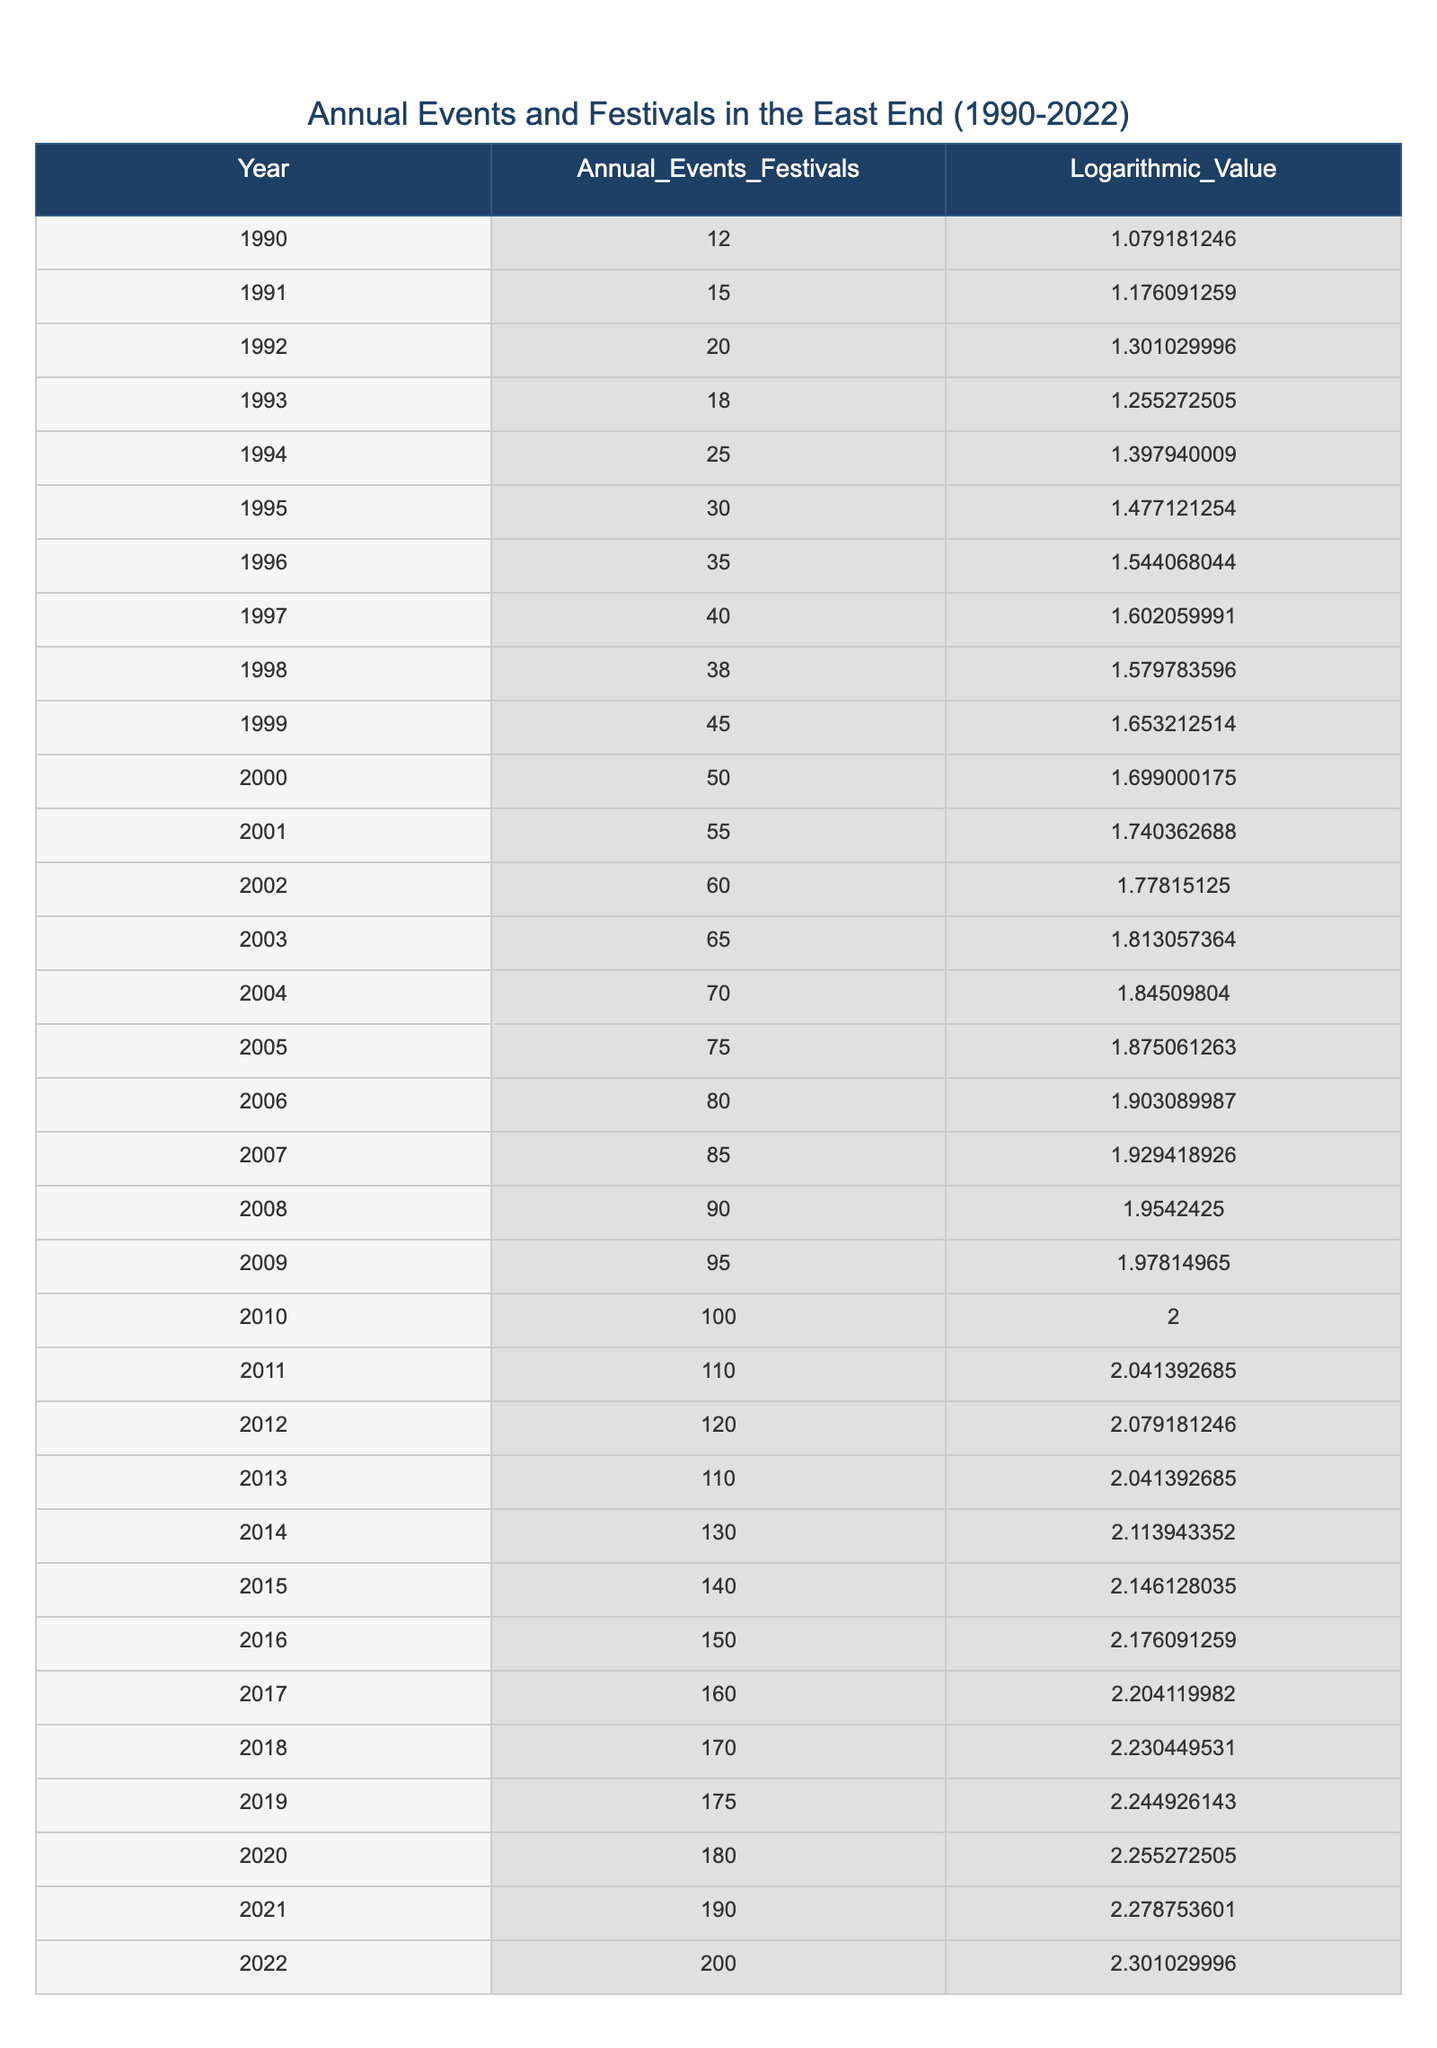What was the annual number of recorded events or festivals in 1995? The value in the row for the year 1995 under the "Annual_Events_Festivals" column is 30. This can be directly referred from the table.
Answer: 30 What is the logarithmic value corresponding to the year 2010? The logarithmic value can be found in the row for the year 2010 under the "Logarithmic_Value" column, which is 2.0.
Answer: 2.0 How many events or festivals were there in total from 1990 to 2022? To find the total, we sum all the values in the "Annual_Events_Festivals" column: 12 + 15 + 20 + 18 + 25 + 30 + 35 + 40 + 38 + 45 + 50 + 55 + 60 + 65 + 70 + 75 + 80 + 85 + 90 + 95 + 100 + 110 + 120 + 110 + 130 + 140 + 150 + 160 + 170 + 175 + 180 + 190 + 200 = 2,732.
Answer: 2732 Was there an increase in the number of events or festivals from the year 2000 to 2002? In the table, the number of events in the year 2000 is 50, and in 2002, it is 60. Since 60 - 50 = 10, this indicates an increase.
Answer: Yes What was the average number of recorded events or festivals from 2010 to 2022? To find the average, we sum the events from 2010 to 2022 (100 + 110 + 120 + 110 + 130 + 140 + 150 + 160 + 170 + 175 + 180 + 190 + 200 = 1,895) and divide by the number of years (13). Thus, 1,895 / 13 = approximately 146.54.
Answer: 146.54 Which year recorded the highest number of events and what was that number? By looking across the "Annual_Events_Festivals" values, we find the highest value is 200 in 2022. Therefore, 2022 had the highest number of events.
Answer: 200 in 2022 What was the change in the number of festivals from 2010 to 2011? Referring to the table, the value in 2010 is 100 and in 2011 is 110. The change is 110 - 100 = 10, indicating an increase of 10.
Answer: Increase of 10 Was there a drop in the number of events from 2012 to 2013? In 2012, the value is 120 and in 2013 it is 110, so there is a drop of 120 - 110 = 10. This indicates a decrease in the number of events.
Answer: Yes 